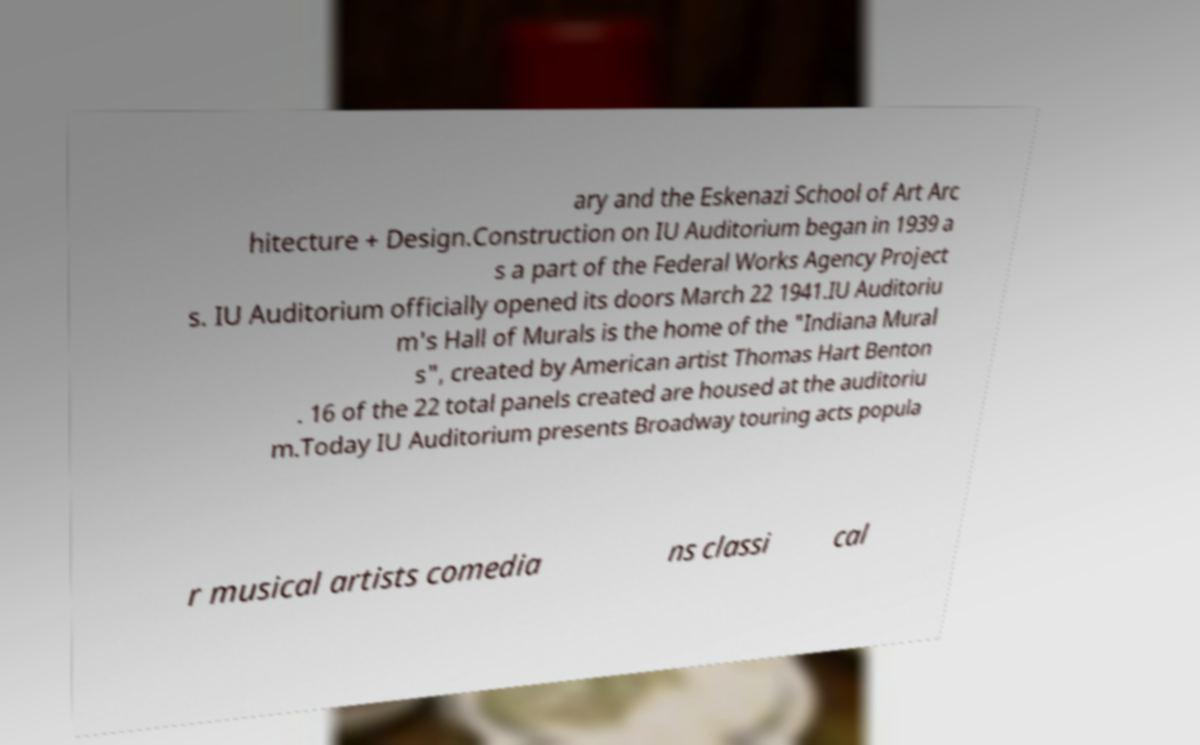I need the written content from this picture converted into text. Can you do that? ary and the Eskenazi School of Art Arc hitecture + Design.Construction on IU Auditorium began in 1939 a s a part of the Federal Works Agency Project s. IU Auditorium officially opened its doors March 22 1941.IU Auditoriu m's Hall of Murals is the home of the "Indiana Mural s", created by American artist Thomas Hart Benton . 16 of the 22 total panels created are housed at the auditoriu m.Today IU Auditorium presents Broadway touring acts popula r musical artists comedia ns classi cal 